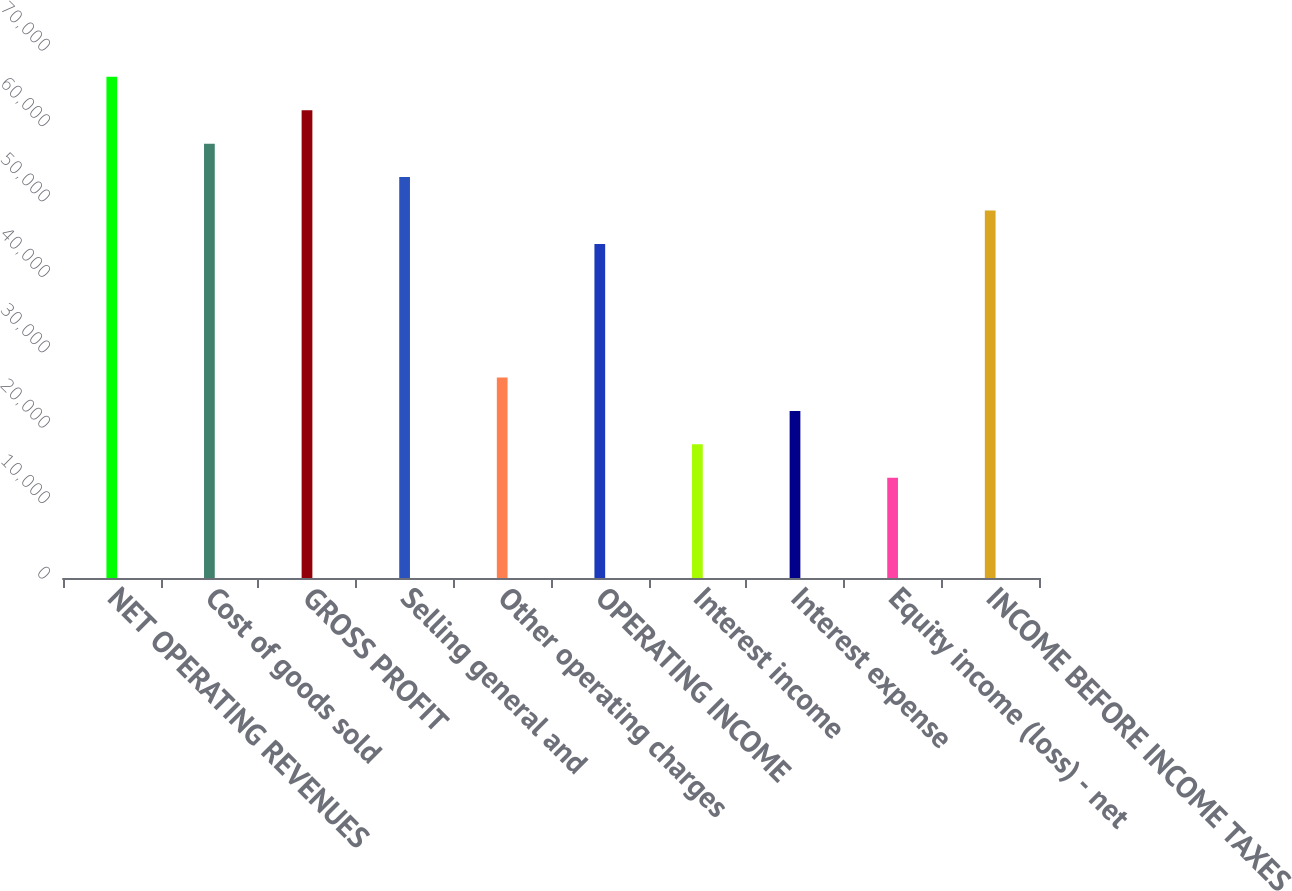<chart> <loc_0><loc_0><loc_500><loc_500><bar_chart><fcel>NET OPERATING REVENUES<fcel>Cost of goods sold<fcel>GROSS PROFIT<fcel>Selling general and<fcel>Other operating charges<fcel>OPERATING INCOME<fcel>Interest income<fcel>Interest expense<fcel>Equity income (loss) - net<fcel>INCOME BEFORE INCOME TAXES<nl><fcel>66440.1<fcel>57581.7<fcel>62010.9<fcel>53152.4<fcel>26577<fcel>44294<fcel>17718.6<fcel>22147.8<fcel>13289.4<fcel>48723.2<nl></chart> 